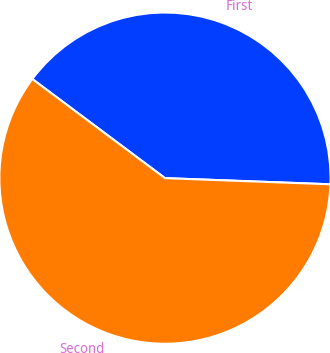Convert chart. <chart><loc_0><loc_0><loc_500><loc_500><pie_chart><fcel>First<fcel>Second<nl><fcel>40.38%<fcel>59.62%<nl></chart> 